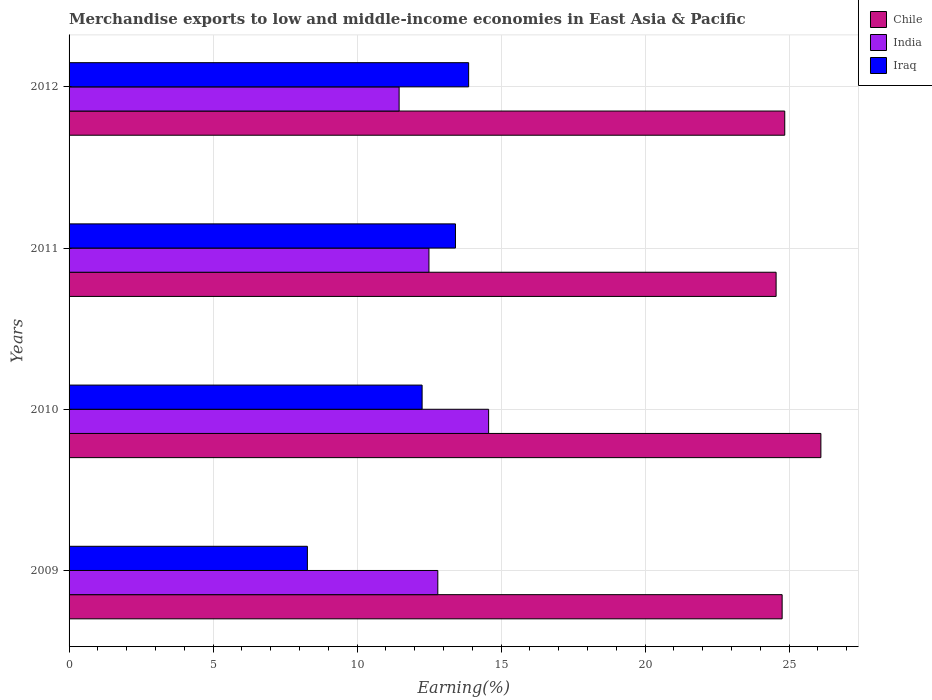How many different coloured bars are there?
Make the answer very short. 3. Are the number of bars per tick equal to the number of legend labels?
Your response must be concise. Yes. Are the number of bars on each tick of the Y-axis equal?
Offer a very short reply. Yes. How many bars are there on the 4th tick from the top?
Offer a very short reply. 3. What is the label of the 2nd group of bars from the top?
Offer a terse response. 2011. In how many cases, is the number of bars for a given year not equal to the number of legend labels?
Give a very brief answer. 0. What is the percentage of amount earned from merchandise exports in Iraq in 2011?
Provide a short and direct response. 13.41. Across all years, what is the maximum percentage of amount earned from merchandise exports in Iraq?
Ensure brevity in your answer.  13.87. Across all years, what is the minimum percentage of amount earned from merchandise exports in India?
Your answer should be compact. 11.46. In which year was the percentage of amount earned from merchandise exports in Iraq maximum?
Make the answer very short. 2012. What is the total percentage of amount earned from merchandise exports in Iraq in the graph?
Make the answer very short. 47.82. What is the difference between the percentage of amount earned from merchandise exports in Iraq in 2009 and that in 2010?
Give a very brief answer. -3.98. What is the difference between the percentage of amount earned from merchandise exports in India in 2009 and the percentage of amount earned from merchandise exports in Chile in 2012?
Your answer should be compact. -12.04. What is the average percentage of amount earned from merchandise exports in India per year?
Ensure brevity in your answer.  12.83. In the year 2011, what is the difference between the percentage of amount earned from merchandise exports in India and percentage of amount earned from merchandise exports in Chile?
Provide a succinct answer. -12.05. What is the ratio of the percentage of amount earned from merchandise exports in Iraq in 2009 to that in 2011?
Offer a terse response. 0.62. What is the difference between the highest and the second highest percentage of amount earned from merchandise exports in Iraq?
Make the answer very short. 0.46. What is the difference between the highest and the lowest percentage of amount earned from merchandise exports in India?
Make the answer very short. 3.11. What does the 1st bar from the top in 2010 represents?
Your answer should be compact. Iraq. What does the 3rd bar from the bottom in 2011 represents?
Keep it short and to the point. Iraq. Are all the bars in the graph horizontal?
Your answer should be compact. Yes. What is the difference between two consecutive major ticks on the X-axis?
Offer a terse response. 5. Does the graph contain any zero values?
Your answer should be compact. No. Does the graph contain grids?
Your response must be concise. Yes. What is the title of the graph?
Ensure brevity in your answer.  Merchandise exports to low and middle-income economies in East Asia & Pacific. Does "American Samoa" appear as one of the legend labels in the graph?
Offer a very short reply. No. What is the label or title of the X-axis?
Your answer should be compact. Earning(%). What is the Earning(%) in Chile in 2009?
Offer a very short reply. 24.76. What is the Earning(%) of India in 2009?
Make the answer very short. 12.8. What is the Earning(%) of Iraq in 2009?
Keep it short and to the point. 8.27. What is the Earning(%) in Chile in 2010?
Provide a succinct answer. 26.1. What is the Earning(%) of India in 2010?
Make the answer very short. 14.57. What is the Earning(%) in Iraq in 2010?
Offer a very short reply. 12.26. What is the Earning(%) in Chile in 2011?
Provide a short and direct response. 24.55. What is the Earning(%) of India in 2011?
Make the answer very short. 12.49. What is the Earning(%) of Iraq in 2011?
Your answer should be very brief. 13.41. What is the Earning(%) in Chile in 2012?
Your answer should be compact. 24.85. What is the Earning(%) of India in 2012?
Provide a short and direct response. 11.46. What is the Earning(%) of Iraq in 2012?
Provide a succinct answer. 13.87. Across all years, what is the maximum Earning(%) in Chile?
Your answer should be very brief. 26.1. Across all years, what is the maximum Earning(%) in India?
Keep it short and to the point. 14.57. Across all years, what is the maximum Earning(%) in Iraq?
Provide a succinct answer. 13.87. Across all years, what is the minimum Earning(%) of Chile?
Offer a very short reply. 24.55. Across all years, what is the minimum Earning(%) of India?
Offer a very short reply. 11.46. Across all years, what is the minimum Earning(%) in Iraq?
Keep it short and to the point. 8.27. What is the total Earning(%) of Chile in the graph?
Your answer should be compact. 100.25. What is the total Earning(%) of India in the graph?
Your answer should be compact. 51.32. What is the total Earning(%) in Iraq in the graph?
Your answer should be very brief. 47.82. What is the difference between the Earning(%) of Chile in 2009 and that in 2010?
Give a very brief answer. -1.35. What is the difference between the Earning(%) in India in 2009 and that in 2010?
Provide a succinct answer. -1.76. What is the difference between the Earning(%) of Iraq in 2009 and that in 2010?
Provide a succinct answer. -3.98. What is the difference between the Earning(%) of Chile in 2009 and that in 2011?
Offer a very short reply. 0.21. What is the difference between the Earning(%) in India in 2009 and that in 2011?
Ensure brevity in your answer.  0.31. What is the difference between the Earning(%) in Iraq in 2009 and that in 2011?
Offer a terse response. -5.14. What is the difference between the Earning(%) in Chile in 2009 and that in 2012?
Your response must be concise. -0.09. What is the difference between the Earning(%) of India in 2009 and that in 2012?
Keep it short and to the point. 1.34. What is the difference between the Earning(%) in Iraq in 2009 and that in 2012?
Ensure brevity in your answer.  -5.6. What is the difference between the Earning(%) of Chile in 2010 and that in 2011?
Offer a very short reply. 1.55. What is the difference between the Earning(%) of India in 2010 and that in 2011?
Provide a succinct answer. 2.07. What is the difference between the Earning(%) of Iraq in 2010 and that in 2011?
Provide a short and direct response. -1.16. What is the difference between the Earning(%) in Chile in 2010 and that in 2012?
Your response must be concise. 1.25. What is the difference between the Earning(%) in India in 2010 and that in 2012?
Your response must be concise. 3.11. What is the difference between the Earning(%) in Iraq in 2010 and that in 2012?
Your response must be concise. -1.62. What is the difference between the Earning(%) of Chile in 2011 and that in 2012?
Give a very brief answer. -0.3. What is the difference between the Earning(%) in India in 2011 and that in 2012?
Offer a very short reply. 1.04. What is the difference between the Earning(%) in Iraq in 2011 and that in 2012?
Make the answer very short. -0.46. What is the difference between the Earning(%) of Chile in 2009 and the Earning(%) of India in 2010?
Give a very brief answer. 10.19. What is the difference between the Earning(%) in Chile in 2009 and the Earning(%) in Iraq in 2010?
Make the answer very short. 12.5. What is the difference between the Earning(%) in India in 2009 and the Earning(%) in Iraq in 2010?
Give a very brief answer. 0.55. What is the difference between the Earning(%) in Chile in 2009 and the Earning(%) in India in 2011?
Your answer should be compact. 12.26. What is the difference between the Earning(%) of Chile in 2009 and the Earning(%) of Iraq in 2011?
Your answer should be very brief. 11.34. What is the difference between the Earning(%) in India in 2009 and the Earning(%) in Iraq in 2011?
Offer a very short reply. -0.61. What is the difference between the Earning(%) in Chile in 2009 and the Earning(%) in India in 2012?
Make the answer very short. 13.3. What is the difference between the Earning(%) in Chile in 2009 and the Earning(%) in Iraq in 2012?
Offer a terse response. 10.88. What is the difference between the Earning(%) of India in 2009 and the Earning(%) of Iraq in 2012?
Offer a very short reply. -1.07. What is the difference between the Earning(%) in Chile in 2010 and the Earning(%) in India in 2011?
Your answer should be compact. 13.61. What is the difference between the Earning(%) of Chile in 2010 and the Earning(%) of Iraq in 2011?
Your answer should be very brief. 12.69. What is the difference between the Earning(%) of India in 2010 and the Earning(%) of Iraq in 2011?
Provide a short and direct response. 1.15. What is the difference between the Earning(%) of Chile in 2010 and the Earning(%) of India in 2012?
Give a very brief answer. 14.64. What is the difference between the Earning(%) in Chile in 2010 and the Earning(%) in Iraq in 2012?
Keep it short and to the point. 12.23. What is the difference between the Earning(%) in India in 2010 and the Earning(%) in Iraq in 2012?
Give a very brief answer. 0.69. What is the difference between the Earning(%) of Chile in 2011 and the Earning(%) of India in 2012?
Your answer should be very brief. 13.09. What is the difference between the Earning(%) in Chile in 2011 and the Earning(%) in Iraq in 2012?
Your response must be concise. 10.67. What is the difference between the Earning(%) in India in 2011 and the Earning(%) in Iraq in 2012?
Give a very brief answer. -1.38. What is the average Earning(%) of Chile per year?
Provide a short and direct response. 25.06. What is the average Earning(%) in India per year?
Your answer should be compact. 12.83. What is the average Earning(%) in Iraq per year?
Offer a very short reply. 11.95. In the year 2009, what is the difference between the Earning(%) in Chile and Earning(%) in India?
Keep it short and to the point. 11.95. In the year 2009, what is the difference between the Earning(%) in Chile and Earning(%) in Iraq?
Offer a very short reply. 16.48. In the year 2009, what is the difference between the Earning(%) in India and Earning(%) in Iraq?
Your answer should be very brief. 4.53. In the year 2010, what is the difference between the Earning(%) of Chile and Earning(%) of India?
Your answer should be very brief. 11.54. In the year 2010, what is the difference between the Earning(%) of Chile and Earning(%) of Iraq?
Provide a succinct answer. 13.84. In the year 2010, what is the difference between the Earning(%) of India and Earning(%) of Iraq?
Give a very brief answer. 2.31. In the year 2011, what is the difference between the Earning(%) of Chile and Earning(%) of India?
Keep it short and to the point. 12.05. In the year 2011, what is the difference between the Earning(%) in Chile and Earning(%) in Iraq?
Your answer should be compact. 11.13. In the year 2011, what is the difference between the Earning(%) of India and Earning(%) of Iraq?
Your response must be concise. -0.92. In the year 2012, what is the difference between the Earning(%) of Chile and Earning(%) of India?
Provide a succinct answer. 13.39. In the year 2012, what is the difference between the Earning(%) in Chile and Earning(%) in Iraq?
Ensure brevity in your answer.  10.97. In the year 2012, what is the difference between the Earning(%) of India and Earning(%) of Iraq?
Your answer should be very brief. -2.41. What is the ratio of the Earning(%) of Chile in 2009 to that in 2010?
Provide a succinct answer. 0.95. What is the ratio of the Earning(%) in India in 2009 to that in 2010?
Provide a short and direct response. 0.88. What is the ratio of the Earning(%) in Iraq in 2009 to that in 2010?
Make the answer very short. 0.68. What is the ratio of the Earning(%) of Chile in 2009 to that in 2011?
Offer a terse response. 1.01. What is the ratio of the Earning(%) in India in 2009 to that in 2011?
Ensure brevity in your answer.  1.02. What is the ratio of the Earning(%) in Iraq in 2009 to that in 2011?
Your answer should be very brief. 0.62. What is the ratio of the Earning(%) of India in 2009 to that in 2012?
Provide a succinct answer. 1.12. What is the ratio of the Earning(%) in Iraq in 2009 to that in 2012?
Your answer should be very brief. 0.6. What is the ratio of the Earning(%) in Chile in 2010 to that in 2011?
Ensure brevity in your answer.  1.06. What is the ratio of the Earning(%) in India in 2010 to that in 2011?
Provide a short and direct response. 1.17. What is the ratio of the Earning(%) of Iraq in 2010 to that in 2011?
Your answer should be compact. 0.91. What is the ratio of the Earning(%) in Chile in 2010 to that in 2012?
Give a very brief answer. 1.05. What is the ratio of the Earning(%) in India in 2010 to that in 2012?
Provide a short and direct response. 1.27. What is the ratio of the Earning(%) in Iraq in 2010 to that in 2012?
Give a very brief answer. 0.88. What is the ratio of the Earning(%) in Chile in 2011 to that in 2012?
Offer a terse response. 0.99. What is the ratio of the Earning(%) of India in 2011 to that in 2012?
Offer a very short reply. 1.09. What is the ratio of the Earning(%) of Iraq in 2011 to that in 2012?
Your answer should be very brief. 0.97. What is the difference between the highest and the second highest Earning(%) of Chile?
Your answer should be very brief. 1.25. What is the difference between the highest and the second highest Earning(%) of India?
Provide a short and direct response. 1.76. What is the difference between the highest and the second highest Earning(%) in Iraq?
Give a very brief answer. 0.46. What is the difference between the highest and the lowest Earning(%) of Chile?
Offer a terse response. 1.55. What is the difference between the highest and the lowest Earning(%) in India?
Provide a succinct answer. 3.11. What is the difference between the highest and the lowest Earning(%) of Iraq?
Make the answer very short. 5.6. 